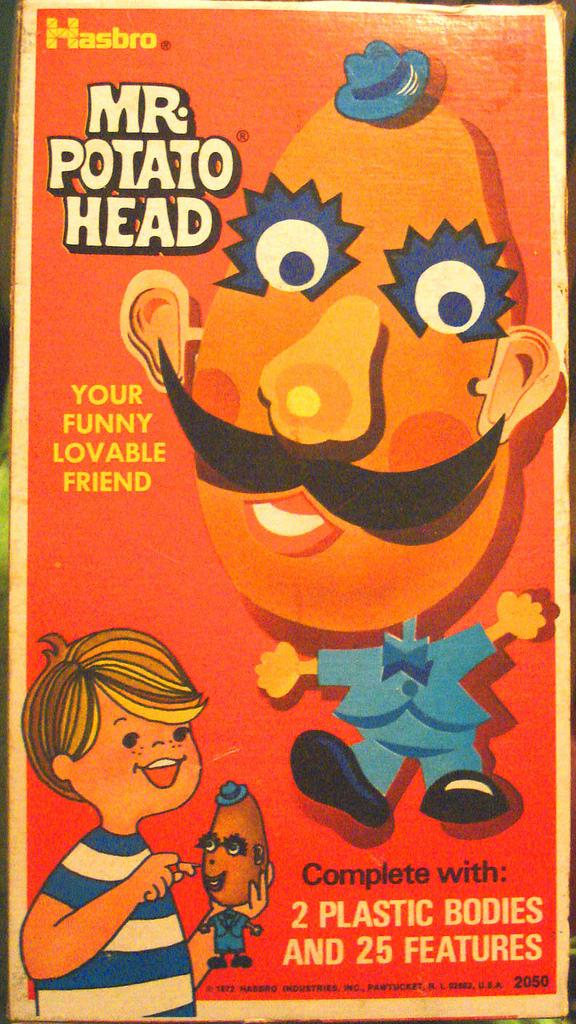<image>
Provide a brief description of the given image. A vintage box for Hasbor's Mr. Potato Head. 